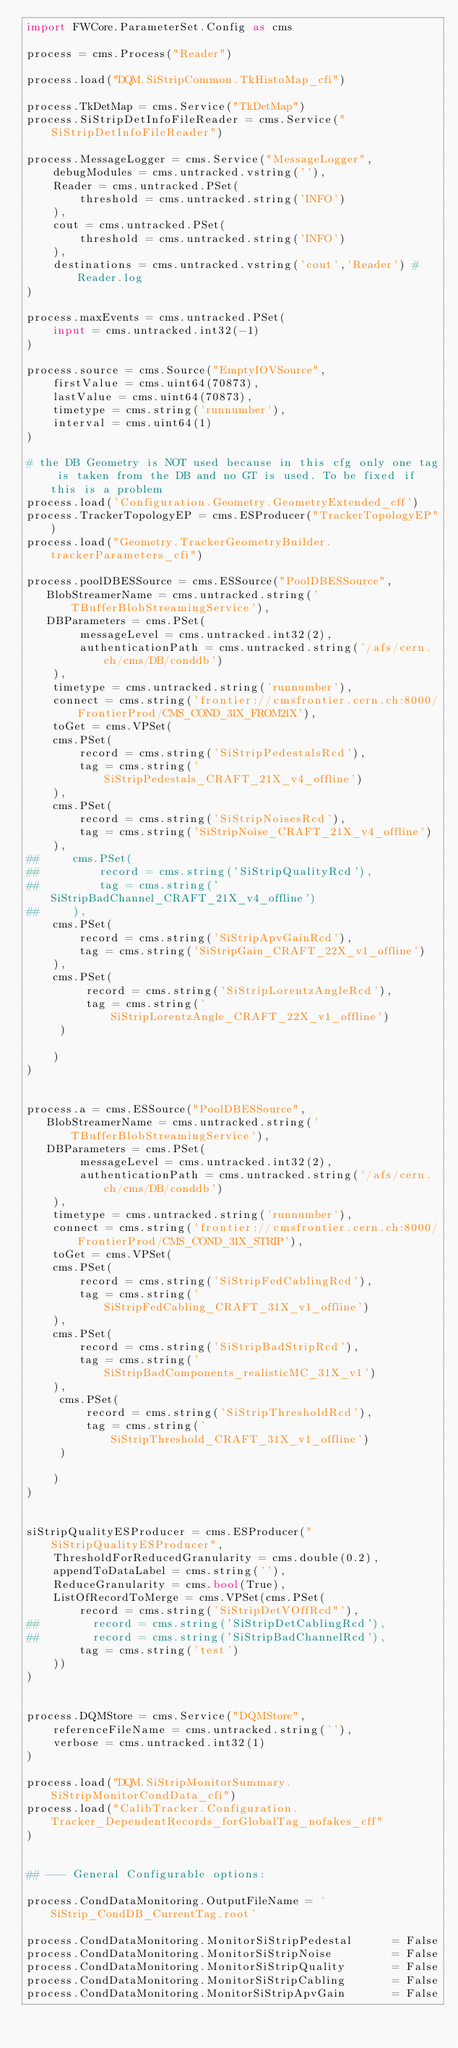Convert code to text. <code><loc_0><loc_0><loc_500><loc_500><_Python_>import FWCore.ParameterSet.Config as cms

process = cms.Process("Reader")

process.load("DQM.SiStripCommon.TkHistoMap_cfi")

process.TkDetMap = cms.Service("TkDetMap")
process.SiStripDetInfoFileReader = cms.Service("SiStripDetInfoFileReader")

process.MessageLogger = cms.Service("MessageLogger",
    debugModules = cms.untracked.vstring(''),
    Reader = cms.untracked.PSet(
        threshold = cms.untracked.string('INFO')
    ),
    cout = cms.untracked.PSet(
        threshold = cms.untracked.string('INFO')
    ),
    destinations = cms.untracked.vstring('cout','Reader') #Reader.log
)

process.maxEvents = cms.untracked.PSet(
    input = cms.untracked.int32(-1)
)

process.source = cms.Source("EmptyIOVSource",
    firstValue = cms.uint64(70873),
    lastValue = cms.uint64(70873),
    timetype = cms.string('runnumber'),
    interval = cms.uint64(1)
)

# the DB Geometry is NOT used because in this cfg only one tag is taken from the DB and no GT is used. To be fixed if this is a problem
process.load('Configuration.Geometry.GeometryExtended_cff')
process.TrackerTopologyEP = cms.ESProducer("TrackerTopologyEP")
process.load("Geometry.TrackerGeometryBuilder.trackerParameters_cfi")

process.poolDBESSource = cms.ESSource("PoolDBESSource",
   BlobStreamerName = cms.untracked.string('TBufferBlobStreamingService'),
   DBParameters = cms.PSet(
        messageLevel = cms.untracked.int32(2),
        authenticationPath = cms.untracked.string('/afs/cern.ch/cms/DB/conddb')
    ),
    timetype = cms.untracked.string('runnumber'),
    connect = cms.string('frontier://cmsfrontier.cern.ch:8000/FrontierProd/CMS_COND_31X_FROM21X'),
    toGet = cms.VPSet(
    cms.PSet(
        record = cms.string('SiStripPedestalsRcd'),
        tag = cms.string('SiStripPedestals_CRAFT_21X_v4_offline')
    ),
    cms.PSet(
        record = cms.string('SiStripNoisesRcd'),
        tag = cms.string('SiStripNoise_CRAFT_21X_v4_offline')
    ),
##     cms.PSet(
##         record = cms.string('SiStripQualityRcd'), 
##         tag = cms.string('SiStripBadChannel_CRAFT_21X_v4_offline') 
##     ),
    cms.PSet(
        record = cms.string('SiStripApvGainRcd'),
        tag = cms.string('SiStripGain_CRAFT_22X_v1_offline') 
    ),
    cms.PSet(
         record = cms.string('SiStripLorentzAngleRcd'),
         tag = cms.string('SiStripLorentzAngle_CRAFT_22X_v1_offline') 
     )
    
    )
)


process.a = cms.ESSource("PoolDBESSource",
   BlobStreamerName = cms.untracked.string('TBufferBlobStreamingService'),
   DBParameters = cms.PSet(
        messageLevel = cms.untracked.int32(2),
        authenticationPath = cms.untracked.string('/afs/cern.ch/cms/DB/conddb')
    ),
    timetype = cms.untracked.string('runnumber'),
    connect = cms.string('frontier://cmsfrontier.cern.ch:8000/FrontierProd/CMS_COND_31X_STRIP'),
    toGet = cms.VPSet(
    cms.PSet(
        record = cms.string('SiStripFedCablingRcd'),
        tag = cms.string('SiStripFedCabling_CRAFT_31X_v1_offline')
    ),
    cms.PSet(
        record = cms.string('SiStripBadStripRcd'), 
        tag = cms.string('SiStripBadComponents_realisticMC_31X_v1') 
    ),
     cms.PSet(
         record = cms.string('SiStripThresholdRcd'),
         tag = cms.string('SiStripThreshold_CRAFT_31X_v1_offline')
     )
   
    )
)


siStripQualityESProducer = cms.ESProducer("SiStripQualityESProducer",
    ThresholdForReducedGranularity = cms.double(0.2),
    appendToDataLabel = cms.string(''),
    ReduceGranularity = cms.bool(True),
    ListOfRecordToMerge = cms.VPSet(cms.PSet(
        record = cms.string('SiStripDetVOffRcd"'),
##        record = cms.string('SiStripDetCablingRcd'),
##        record = cms.string('SiStripBadChannelRcd'),        
        tag = cms.string('test')
    ))
)


process.DQMStore = cms.Service("DQMStore",
    referenceFileName = cms.untracked.string(''),
    verbose = cms.untracked.int32(1)
)

process.load("DQM.SiStripMonitorSummary.SiStripMonitorCondData_cfi")
process.load("CalibTracker.Configuration.Tracker_DependentRecords_forGlobalTag_nofakes_cff"
)


## --- General Configurable options:

process.CondDataMonitoring.OutputFileName = 'SiStrip_CondDB_CurrentTag.root'

process.CondDataMonitoring.MonitorSiStripPedestal      = False
process.CondDataMonitoring.MonitorSiStripNoise         = False
process.CondDataMonitoring.MonitorSiStripQuality       = False
process.CondDataMonitoring.MonitorSiStripCabling       = False
process.CondDataMonitoring.MonitorSiStripApvGain       = False</code> 